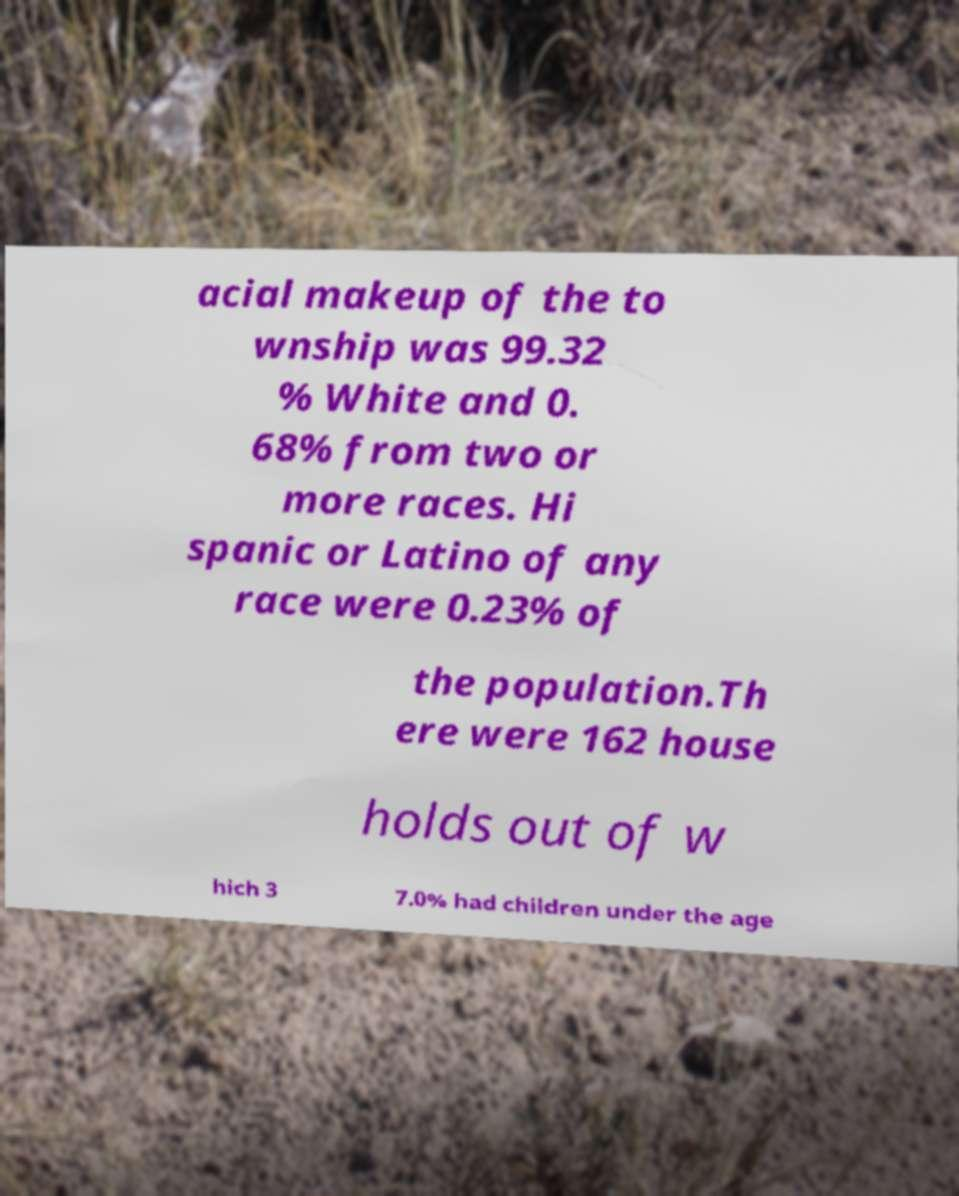Could you extract and type out the text from this image? acial makeup of the to wnship was 99.32 % White and 0. 68% from two or more races. Hi spanic or Latino of any race were 0.23% of the population.Th ere were 162 house holds out of w hich 3 7.0% had children under the age 